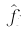<formula> <loc_0><loc_0><loc_500><loc_500>\hat { f _ { j } }</formula> 